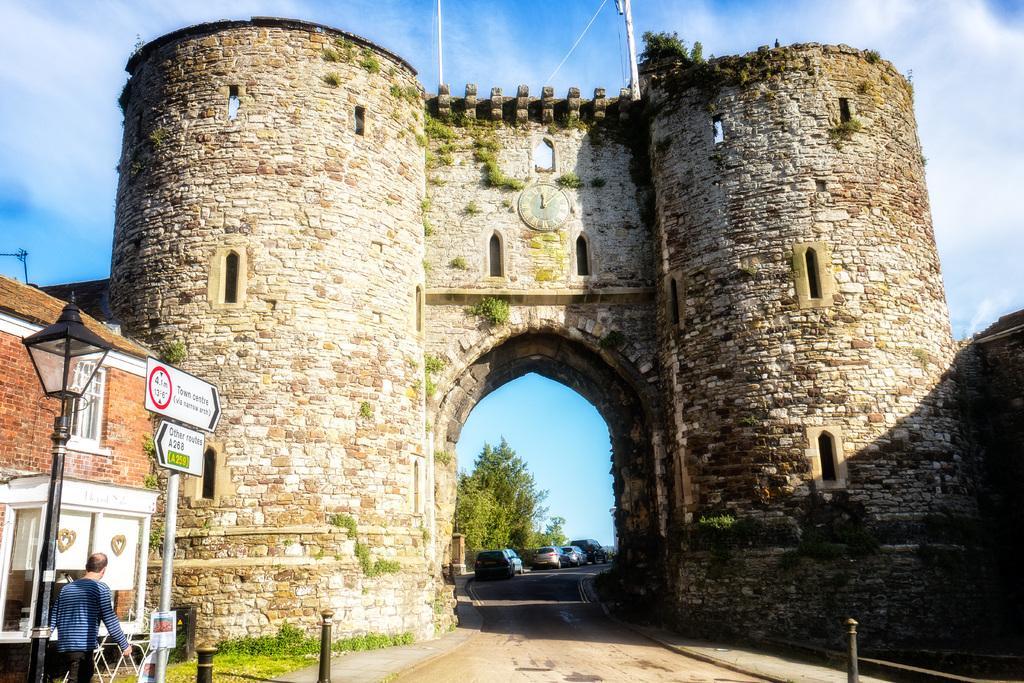How would you summarize this image in a sentence or two? In this image there is a road. There are vehicles and trees. There is a person on the left side and also we can see street light. There is a house. We can see an arch made of stones. There is sky. 